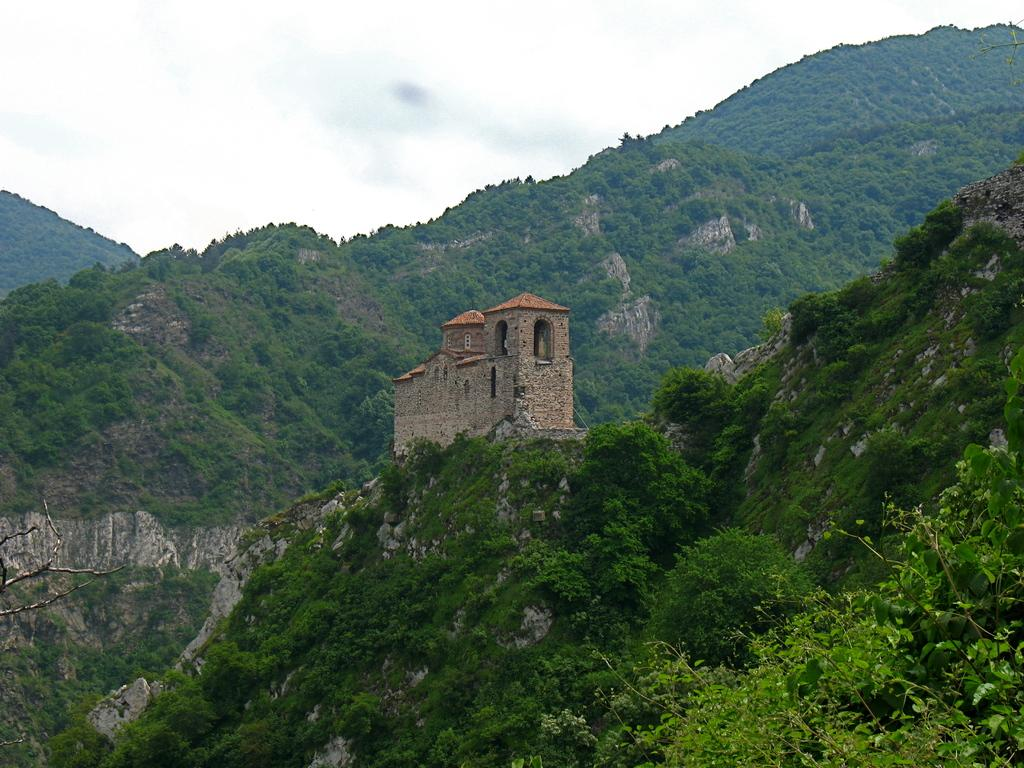What type of natural features can be seen in the image? There are trees and mountains in the image. What type of structure is present in the image? There is a house in the image. What is visible in the background of the image? The sky is visible in the background of the image. What color is the crayon used to draw the mountains in the image? There is no crayon present in the image; it is a photograph or illustration of actual mountains. What type of jewel can be seen on the roof of the house in the image? There is no jewel present on the roof of the house in the image. 